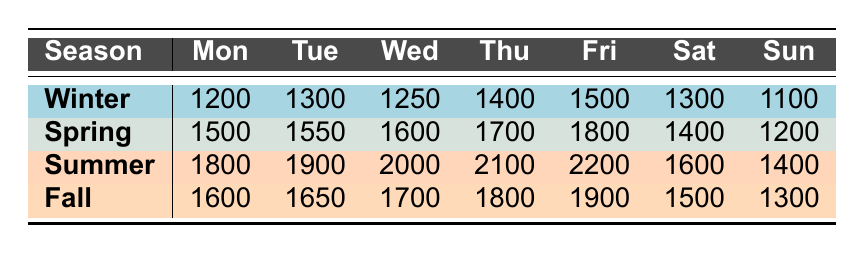What is the highest package volume recorded on a Friday? From the table, the values for Friday across seasons are: Winter 1500, Spring 1800, Summer 2200, and Fall 1900. The highest among these values is 2200 in Summer.
Answer: 2200 Which day of the week has the lowest package volume in Winter? The values for Winter are: Monday 1200, Tuesday 1300, Wednesday 1250, Thursday 1400, Friday 1500, Saturday 1300, and Sunday 1100. The lowest value is 1100 on Sunday.
Answer: 1100 What is the total package volume for Spring across all days of the week? The Spring package volumes are: Monday 1500, Tuesday 1550, Wednesday 1600, Thursday 1700, Friday 1800, Saturday 1400, and Sunday 1200. Adding these values gives: 1500 + 1550 + 1600 + 1700 + 1800 + 1400 + 1200 = 10300.
Answer: 10300 Is the package volume higher on Thursdays compared to Saturdays in Summer? The Summer values are: Thursday 2100 and Saturday 1600. Since 2100 is greater than 1600, it confirms Thursday has a higher volume.
Answer: Yes What is the average package volume for Fall across the week? The Fall package volumes are: Monday 1600, Tuesday 1650, Wednesday 1700, Thursday 1800, Friday 1900, Saturday 1500, and Sunday 1300. Summing these gives: 1600 + 1650 + 1700 + 1800 + 1900 + 1500 + 1300 = 11550. Dividing by 7 (the number of days) gives an average of 11550 / 7 = 1650.
Answer: 1650 Which season has the highest total package volume on Tuesday? The Tuesday values are: Winter 1300, Spring 1550, Summer 1900, and Fall 1650. The highest value on Tuesday is in Summer with 1900.
Answer: Summer What is the difference in package volume between Winter and Summer on Sundays? Looking at the table, Winter volume on Sunday is 1100, and Summer volume is 1400. The difference is 1400 - 1100 = 300.
Answer: 300 In which season is the package volume on Wednesday the highest? The values for Wednesday are: Winter 1250, Spring 1600, Summer 2000, and Fall 1700. The highest volume is 2000 in Summer.
Answer: Summer 